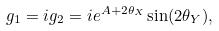Convert formula to latex. <formula><loc_0><loc_0><loc_500><loc_500>g _ { 1 } = i g _ { 2 } = i e ^ { A + 2 \theta _ { X } } \sin ( 2 \theta _ { Y } ) ,</formula> 